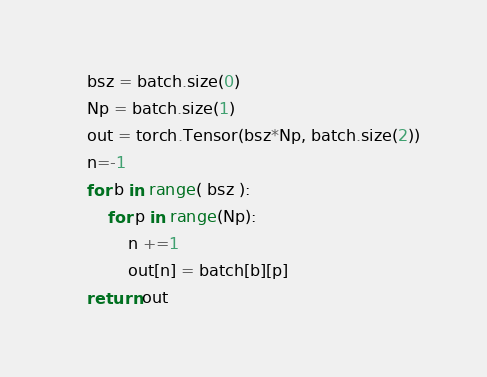Convert code to text. <code><loc_0><loc_0><loc_500><loc_500><_Python_>    bsz = batch.size(0)
    Np = batch.size(1)
    out = torch.Tensor(bsz*Np, batch.size(2))
    n=-1
    for b in range( bsz ):
        for p in range(Np):
            n +=1
            out[n] = batch[b][p]
    return out
</code> 